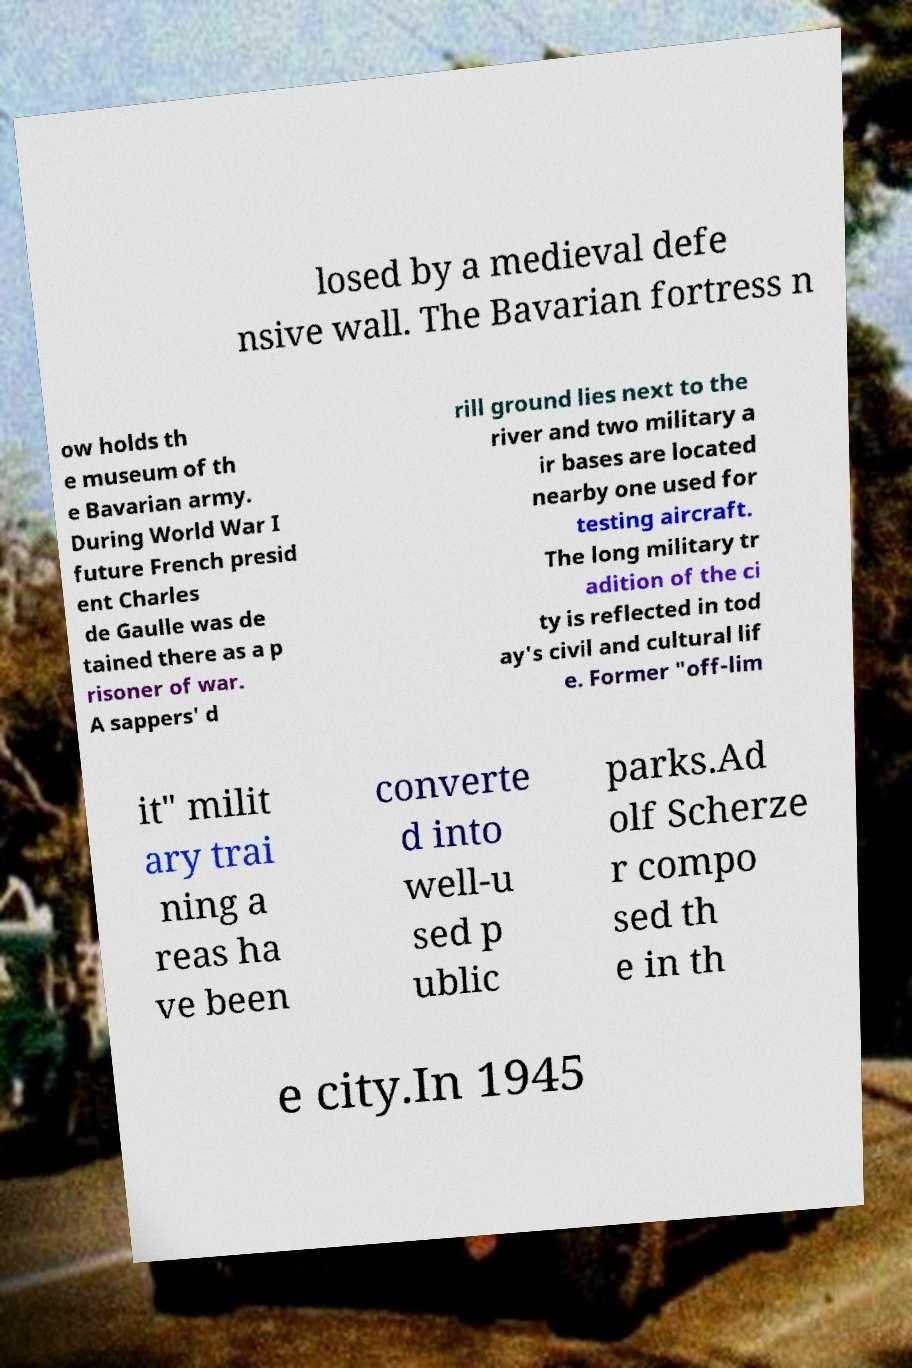Could you assist in decoding the text presented in this image and type it out clearly? losed by a medieval defe nsive wall. The Bavarian fortress n ow holds th e museum of th e Bavarian army. During World War I future French presid ent Charles de Gaulle was de tained there as a p risoner of war. A sappers' d rill ground lies next to the river and two military a ir bases are located nearby one used for testing aircraft. The long military tr adition of the ci ty is reflected in tod ay's civil and cultural lif e. Former "off-lim it" milit ary trai ning a reas ha ve been converte d into well-u sed p ublic parks.Ad olf Scherze r compo sed th e in th e city.In 1945 